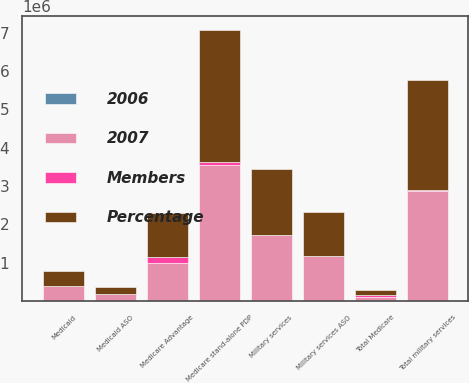Convert chart to OTSL. <chart><loc_0><loc_0><loc_500><loc_500><stacked_bar_chart><ecel><fcel>Medicare Advantage<fcel>Medicare stand-alone PDP<fcel>Total Medicare<fcel>Military services<fcel>Military services ASO<fcel>Total military services<fcel>Medicaid<fcel>Medicaid ASO<nl><fcel>Percentage<fcel>1.143e+06<fcel>3.442e+06<fcel>117500<fcel>1.7191e+06<fcel>1.1468e+06<fcel>2.8659e+06<fcel>384400<fcel>180600<nl><fcel>2007<fcel>1.0026e+06<fcel>3.5366e+06<fcel>117500<fcel>1.7164e+06<fcel>1.1636e+06<fcel>2.88e+06<fcel>390700<fcel>178400<nl><fcel>Members<fcel>140400<fcel>94600<fcel>45800<fcel>2700<fcel>16800<fcel>14100<fcel>6300<fcel>2200<nl><fcel>2006<fcel>14<fcel>2.7<fcel>1<fcel>0.2<fcel>1.4<fcel>0.5<fcel>1.6<fcel>1.2<nl></chart> 